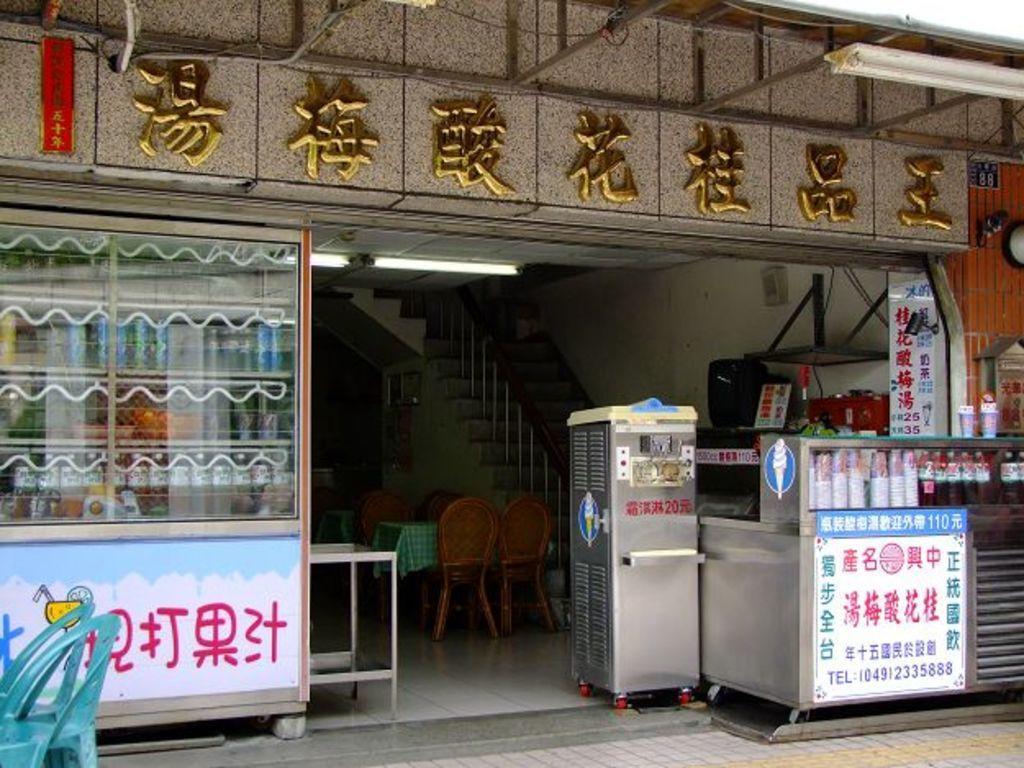Please provide a concise description of this image. This image is taken outdoors. At the bottom of the image there is a floor. On the left side of the image there is a stall and there is a board with a text on it. There are two empty chairs on the floor. On the right side of the image there is another stall with a few boards and there is a text on the boards. There are a few glasses and tumblers in the stall. At the top of the image there is a wall with a text on it and there is a light. In the middle of the image there are a few stairs without railing. There is a table with a tablecloth and there are four empty chairs. 